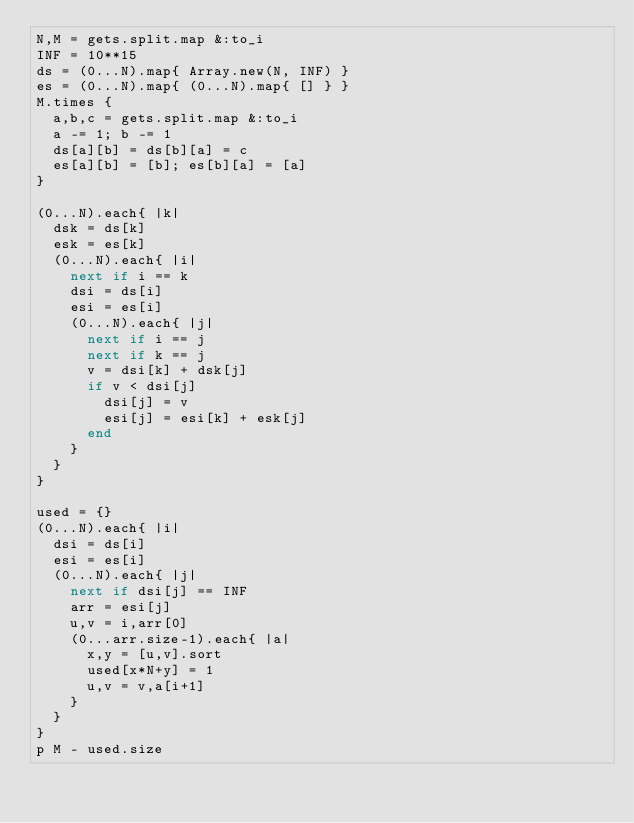Convert code to text. <code><loc_0><loc_0><loc_500><loc_500><_Ruby_>N,M = gets.split.map &:to_i
INF = 10**15
ds = (0...N).map{ Array.new(N, INF) }
es = (0...N).map{ (0...N).map{ [] } }
M.times {
  a,b,c = gets.split.map &:to_i
  a -= 1; b -= 1
  ds[a][b] = ds[b][a] = c
  es[a][b] = [b]; es[b][a] = [a]
}

(0...N).each{ |k|
  dsk = ds[k]
  esk = es[k]
  (0...N).each{ |i|
    next if i == k
    dsi = ds[i]
    esi = es[i]
    (0...N).each{ |j|
      next if i == j
      next if k == j
      v = dsi[k] + dsk[j]
      if v < dsi[j]
        dsi[j] = v
        esi[j] = esi[k] + esk[j]
      end
    }
  }
}

used = {}
(0...N).each{ |i|
  dsi = ds[i]
  esi = es[i]
  (0...N).each{ |j|
    next if dsi[j] == INF
    arr = esi[j]
    u,v = i,arr[0]
    (0...arr.size-1).each{ |a|
      x,y = [u,v].sort
      used[x*N+y] = 1
      u,v = v,a[i+1]
    }
  }
}
p M - used.size

</code> 